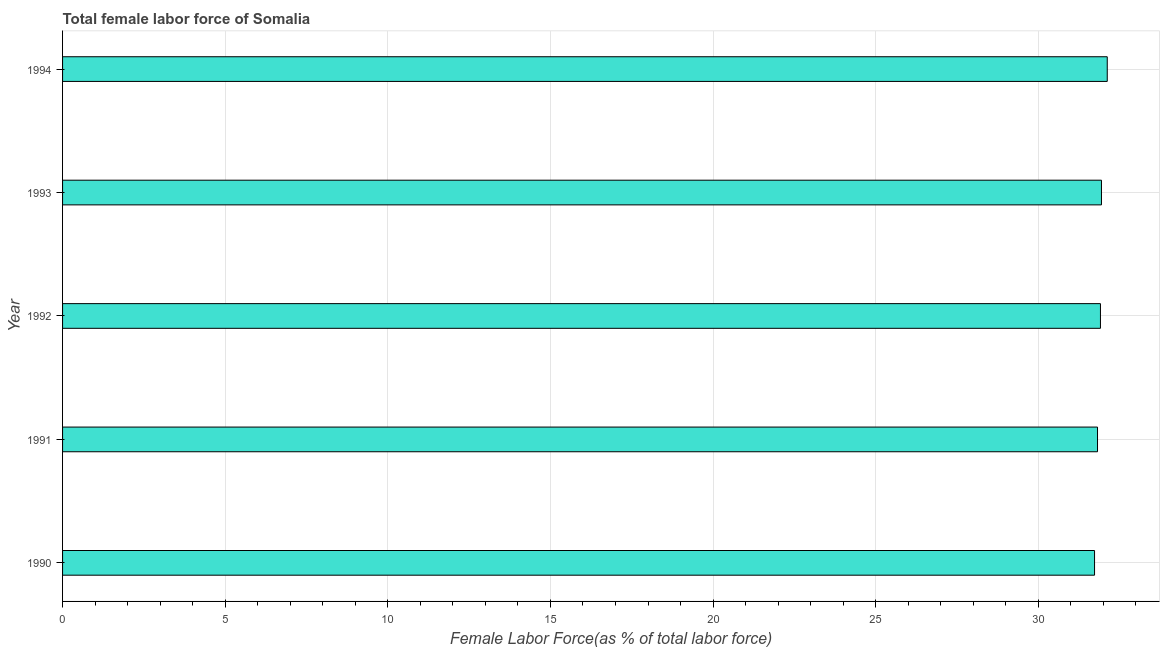Does the graph contain grids?
Keep it short and to the point. Yes. What is the title of the graph?
Your response must be concise. Total female labor force of Somalia. What is the label or title of the X-axis?
Your answer should be very brief. Female Labor Force(as % of total labor force). What is the total female labor force in 1994?
Your response must be concise. 32.12. Across all years, what is the maximum total female labor force?
Your response must be concise. 32.12. Across all years, what is the minimum total female labor force?
Give a very brief answer. 31.73. In which year was the total female labor force minimum?
Provide a short and direct response. 1990. What is the sum of the total female labor force?
Make the answer very short. 159.52. What is the difference between the total female labor force in 1993 and 1994?
Your response must be concise. -0.18. What is the average total female labor force per year?
Offer a very short reply. 31.9. What is the median total female labor force?
Your response must be concise. 31.91. In how many years, is the total female labor force greater than 32 %?
Keep it short and to the point. 1. Do a majority of the years between 1991 and 1993 (inclusive) have total female labor force greater than 9 %?
Ensure brevity in your answer.  Yes. What is the ratio of the total female labor force in 1993 to that in 1994?
Offer a very short reply. 0.99. Is the total female labor force in 1990 less than that in 1992?
Give a very brief answer. Yes. What is the difference between the highest and the second highest total female labor force?
Your answer should be compact. 0.18. What is the difference between the highest and the lowest total female labor force?
Make the answer very short. 0.39. In how many years, is the total female labor force greater than the average total female labor force taken over all years?
Offer a very short reply. 3. How many bars are there?
Keep it short and to the point. 5. Are all the bars in the graph horizontal?
Provide a succinct answer. Yes. Are the values on the major ticks of X-axis written in scientific E-notation?
Provide a succinct answer. No. What is the Female Labor Force(as % of total labor force) of 1990?
Your response must be concise. 31.73. What is the Female Labor Force(as % of total labor force) of 1991?
Provide a short and direct response. 31.82. What is the Female Labor Force(as % of total labor force) of 1992?
Provide a short and direct response. 31.91. What is the Female Labor Force(as % of total labor force) of 1993?
Your response must be concise. 31.94. What is the Female Labor Force(as % of total labor force) of 1994?
Offer a terse response. 32.12. What is the difference between the Female Labor Force(as % of total labor force) in 1990 and 1991?
Ensure brevity in your answer.  -0.09. What is the difference between the Female Labor Force(as % of total labor force) in 1990 and 1992?
Ensure brevity in your answer.  -0.18. What is the difference between the Female Labor Force(as % of total labor force) in 1990 and 1993?
Your answer should be compact. -0.21. What is the difference between the Female Labor Force(as % of total labor force) in 1990 and 1994?
Your response must be concise. -0.39. What is the difference between the Female Labor Force(as % of total labor force) in 1991 and 1992?
Your answer should be compact. -0.09. What is the difference between the Female Labor Force(as % of total labor force) in 1991 and 1993?
Provide a succinct answer. -0.12. What is the difference between the Female Labor Force(as % of total labor force) in 1991 and 1994?
Give a very brief answer. -0.3. What is the difference between the Female Labor Force(as % of total labor force) in 1992 and 1993?
Ensure brevity in your answer.  -0.03. What is the difference between the Female Labor Force(as % of total labor force) in 1992 and 1994?
Give a very brief answer. -0.21. What is the difference between the Female Labor Force(as % of total labor force) in 1993 and 1994?
Offer a very short reply. -0.18. What is the ratio of the Female Labor Force(as % of total labor force) in 1990 to that in 1991?
Provide a succinct answer. 1. What is the ratio of the Female Labor Force(as % of total labor force) in 1990 to that in 1994?
Your answer should be very brief. 0.99. What is the ratio of the Female Labor Force(as % of total labor force) in 1991 to that in 1992?
Your response must be concise. 1. What is the ratio of the Female Labor Force(as % of total labor force) in 1991 to that in 1993?
Keep it short and to the point. 1. What is the ratio of the Female Labor Force(as % of total labor force) in 1991 to that in 1994?
Offer a very short reply. 0.99. What is the ratio of the Female Labor Force(as % of total labor force) in 1992 to that in 1994?
Provide a short and direct response. 0.99. What is the ratio of the Female Labor Force(as % of total labor force) in 1993 to that in 1994?
Provide a short and direct response. 0.99. 